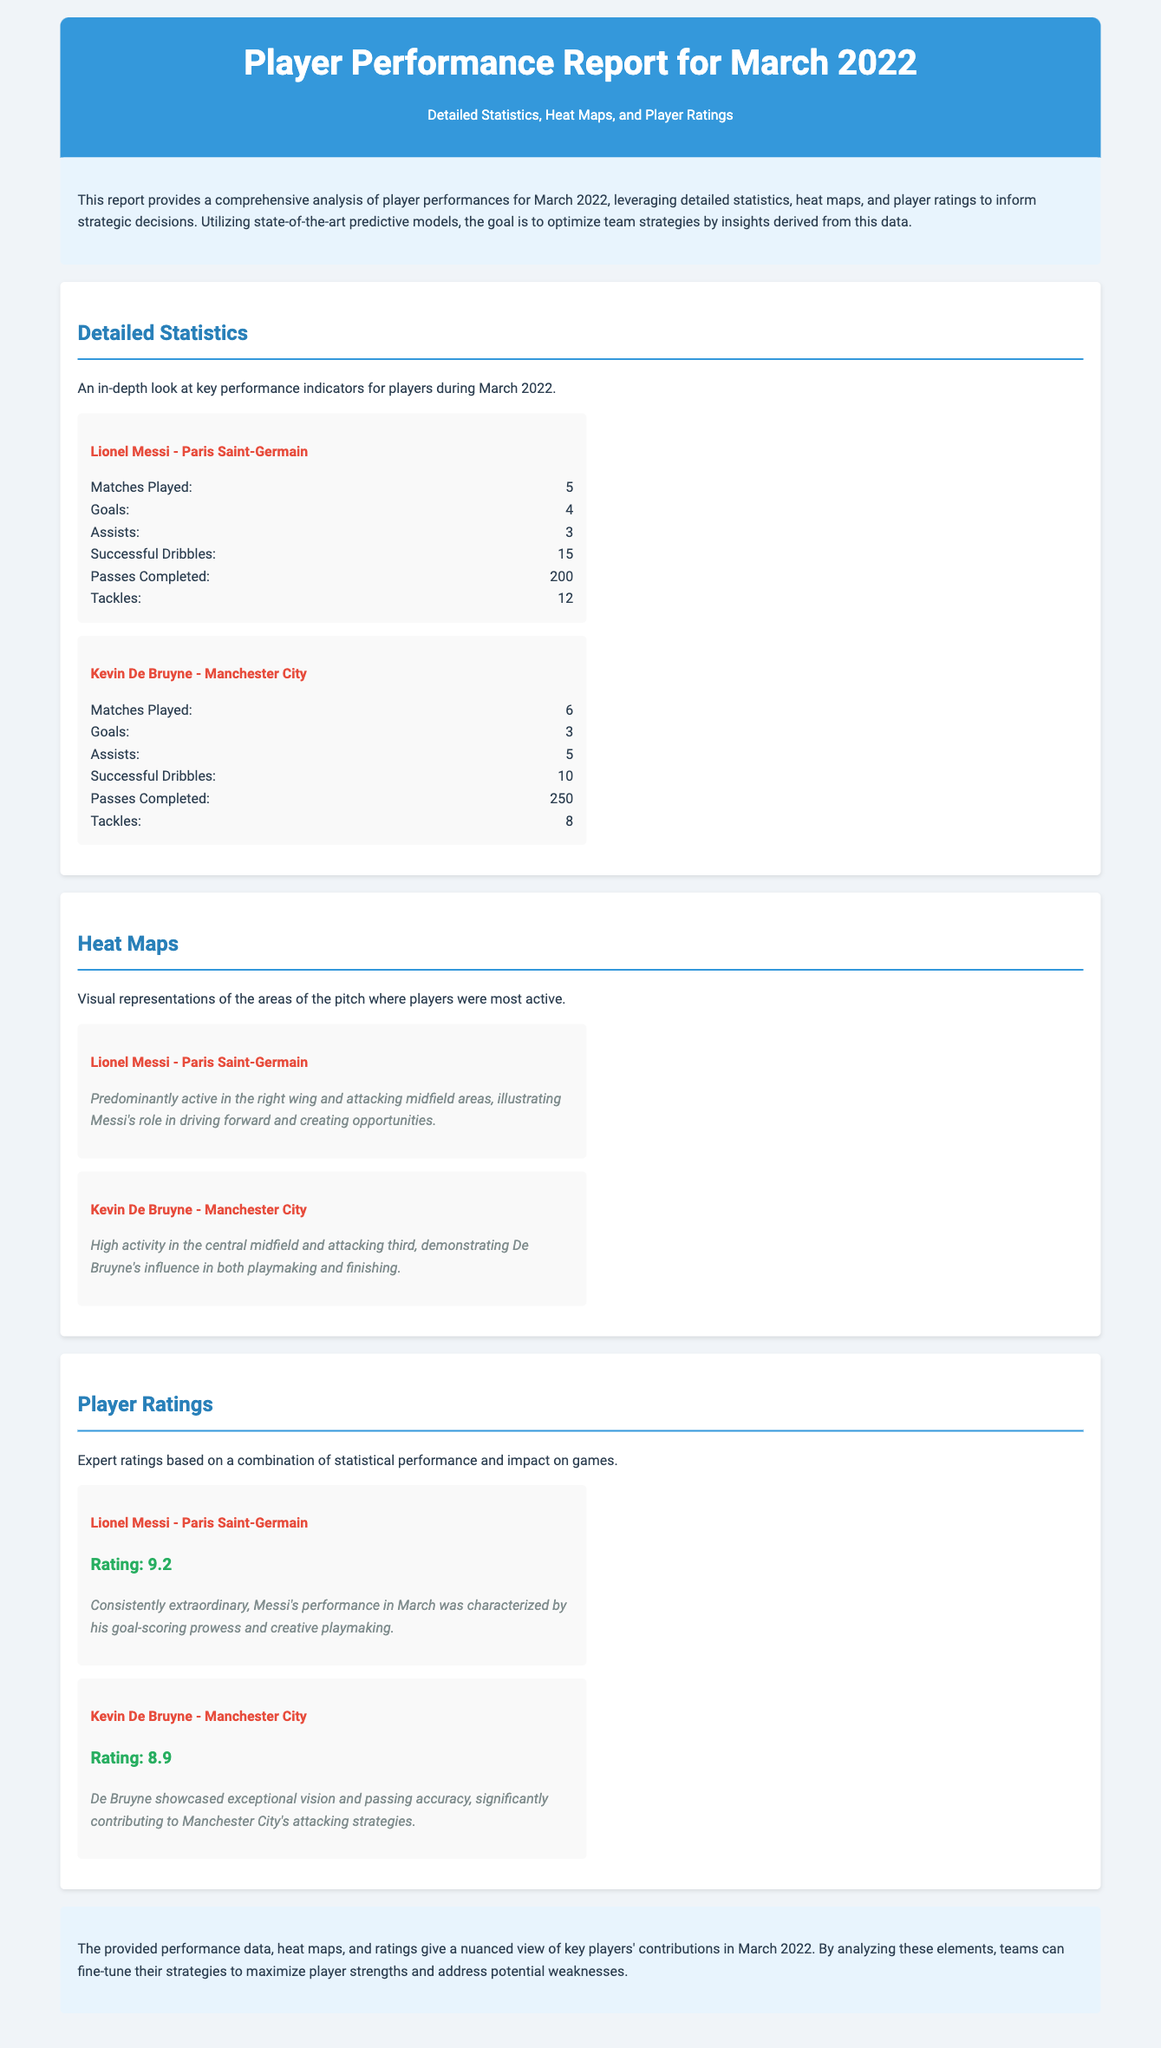What is the title of the report? The title is presented in the header of the document, which indicates the focus and time frame of the report.
Answer: Player Performance Report for March 2022 How many matches did Lionel Messi play? The specific statistics for each player are listed under Detailed Statistics, showing individual performances in matches.
Answer: 5 What is Kevin De Bruyne's assists count? The assists statistic for each player is displayed, enabling comparisons of their contributions.
Answer: 5 What is Lionel Messi's player rating? The ratings for each player are highlighted in the ratings section, providing insights into their overall performances.
Answer: 9.2 In which areas was Lionel Messi predominantly active? The heat map descriptions provide insights into player activities, detailing their movement on the pitch.
Answer: Right wing and attacking midfield areas Which player had the highest number of successful dribbles? The successful dribbles count is provided for both players, requiring comparative analysis to determine the leader.
Answer: Lionel Messi What was the conclusion about the performance data? The conclusion summarizes the document's findings and implications for strategic decisions based on player performances.
Answer: Key players' contributions enable strategy optimization What document style is used for player performances? The type of analytics presented is specific to the context of soccer player evaluations, shown through structured performance indicators.
Answer: Player Performance Report 